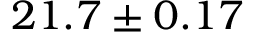<formula> <loc_0><loc_0><loc_500><loc_500>2 1 . 7 \pm 0 . 1 7</formula> 